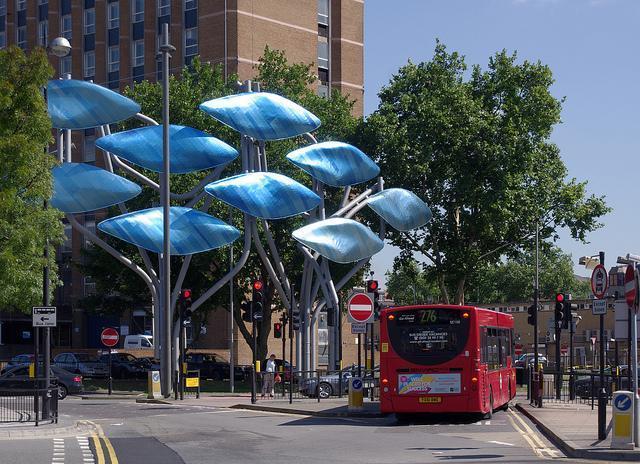How many adult giraffes are in the image?
Give a very brief answer. 0. 